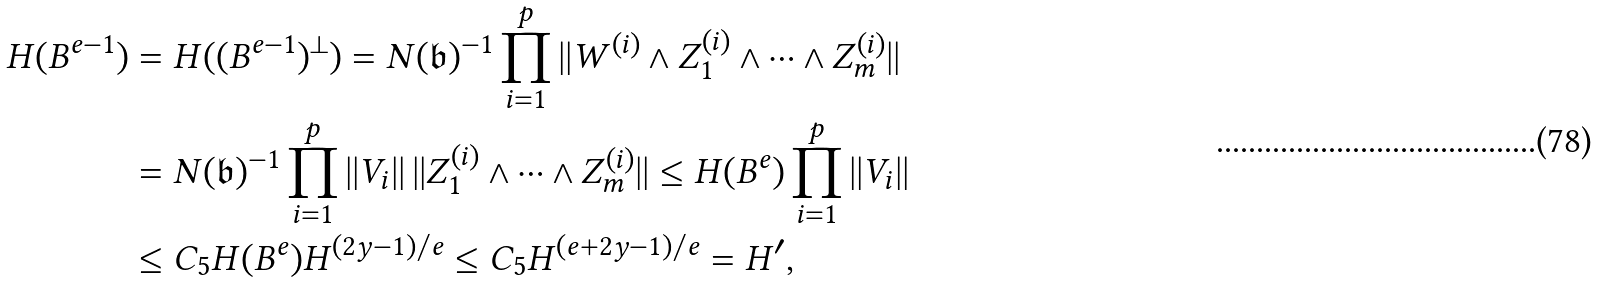<formula> <loc_0><loc_0><loc_500><loc_500>H ( B ^ { e - 1 } ) & = H ( ( B ^ { e - 1 } ) ^ { \perp } ) = N ( \mathfrak { b } ) ^ { - 1 } \prod _ { i = 1 } ^ { p } | | W ^ { ( i ) } \wedge Z _ { 1 } ^ { ( i ) } \wedge \dots \wedge Z _ { m } ^ { ( i ) } | | \\ & = N ( \mathfrak { b } ) ^ { - 1 } \prod _ { i = 1 } ^ { p } | | V _ { i } | | \, | | Z _ { 1 } ^ { ( i ) } \wedge \dots \wedge Z _ { m } ^ { ( i ) } | | \leq H ( B ^ { e } ) \prod _ { i = 1 } ^ { p } | | V _ { i } | | \\ & \leq C _ { 5 } H ( B ^ { e } ) H ^ { ( 2 y - 1 ) / e } \leq C _ { 5 } H ^ { ( e + 2 y - 1 ) / e } = H ^ { \prime } ,</formula> 